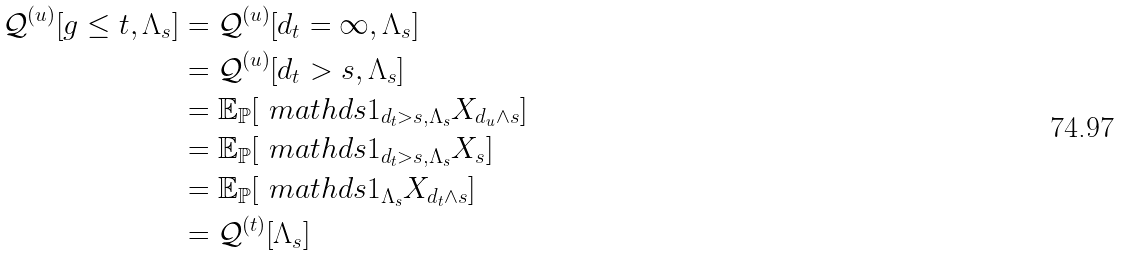<formula> <loc_0><loc_0><loc_500><loc_500>\mathcal { Q } ^ { ( u ) } [ g \leq t , \Lambda _ { s } ] & = \mathcal { Q } ^ { ( u ) } [ d _ { t } = \infty , \Lambda _ { s } ] \\ & = \mathcal { Q } ^ { ( u ) } [ d _ { t } > s , \Lambda _ { s } ] \\ & = \mathbb { E } _ { \mathbb { P } } [ \ m a t h d s { 1 } _ { d _ { t } > s , \Lambda _ { s } } X _ { d _ { u } \wedge s } ] \\ & = \mathbb { E } _ { \mathbb { P } } [ \ m a t h d s { 1 } _ { d _ { t } > s , \Lambda _ { s } } X _ { s } ] \\ & = \mathbb { E } _ { \mathbb { P } } [ \ m a t h d s { 1 } _ { \Lambda _ { s } } X _ { d _ { t } \wedge s } ] \\ & = \mathcal { Q } ^ { ( t ) } [ \Lambda _ { s } ]</formula> 